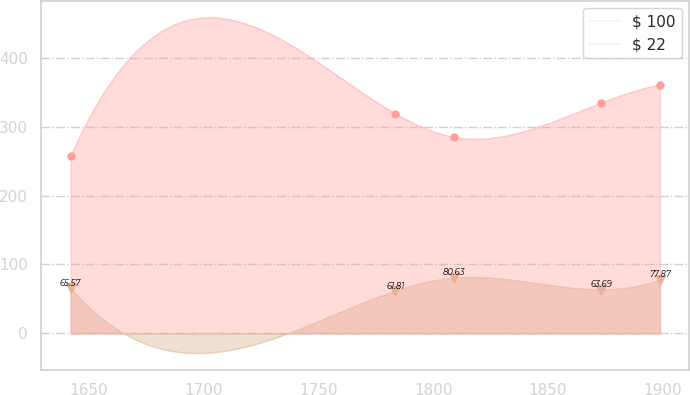<chart> <loc_0><loc_0><loc_500><loc_500><line_chart><ecel><fcel>$ 100<fcel>$ 22<nl><fcel>1641.97<fcel>65.57<fcel>257.52<nl><fcel>1783.54<fcel>61.81<fcel>318.71<nl><fcel>1809.17<fcel>80.63<fcel>284.67<nl><fcel>1873.2<fcel>63.69<fcel>334.39<nl><fcel>1898.83<fcel>77.87<fcel>360.49<nl></chart> 